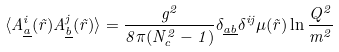Convert formula to latex. <formula><loc_0><loc_0><loc_500><loc_500>\langle A ^ { i } _ { \underline { a } } ( \vec { r } ) A ^ { j } _ { \underline { b } } ( \vec { r } ) \rangle = \frac { g ^ { 2 } } { 8 \pi ( N _ { c } ^ { 2 } - 1 ) } \delta _ { \underline { a b } } \delta ^ { i j } \mu ( \vec { r } ) \ln \frac { Q ^ { 2 } } { m ^ { 2 } }</formula> 